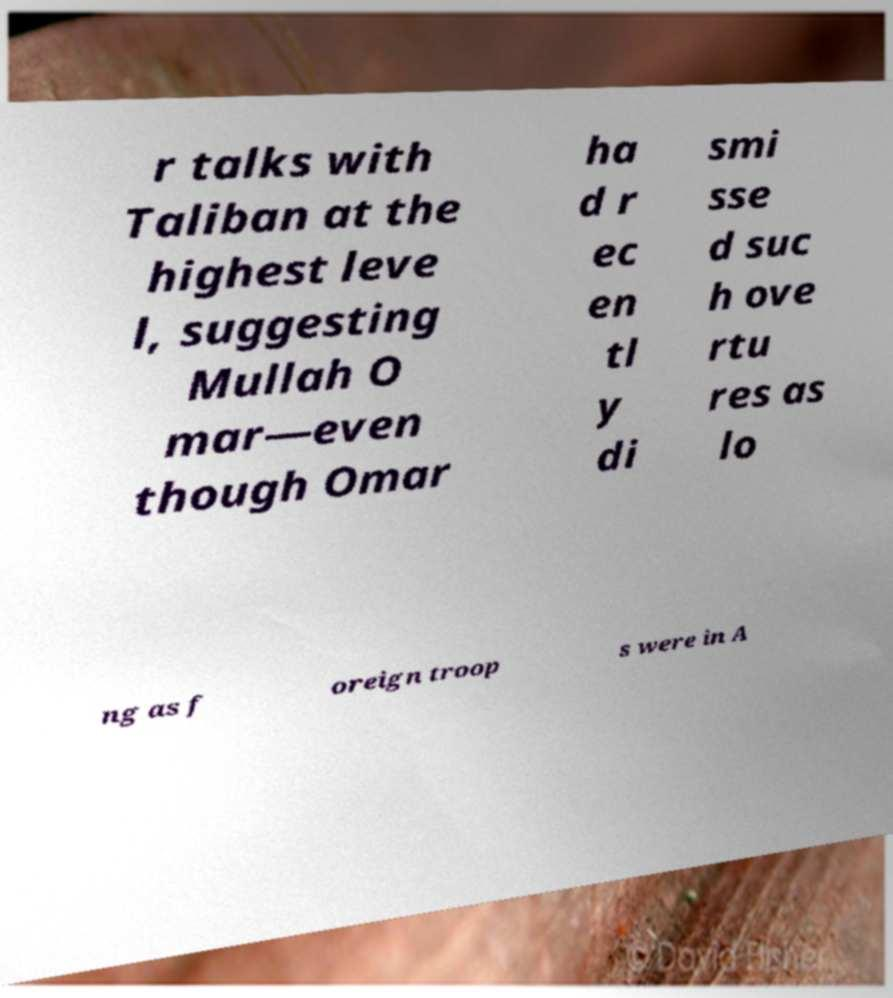Can you accurately transcribe the text from the provided image for me? r talks with Taliban at the highest leve l, suggesting Mullah O mar—even though Omar ha d r ec en tl y di smi sse d suc h ove rtu res as lo ng as f oreign troop s were in A 